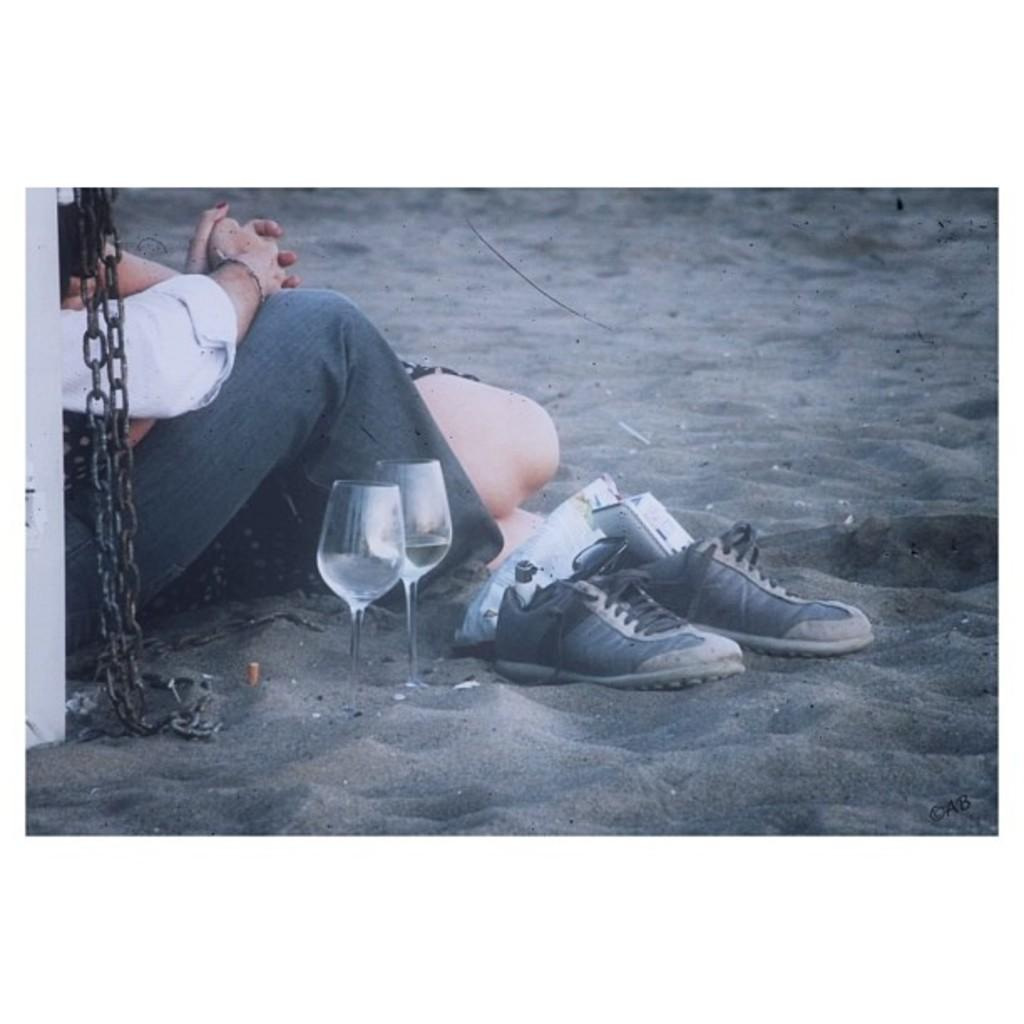How many people are in the image? There is a boy and a girl in the image. Where are the boy and girl located in the image? Both the boy and girl are on the left side of the image. What objects can be seen in the center of the image? There are two glasses and a pair of shoes in the center of the image. What type of pizzas can be smelled in the image? There is no mention of pizzas or any smell in the image. 